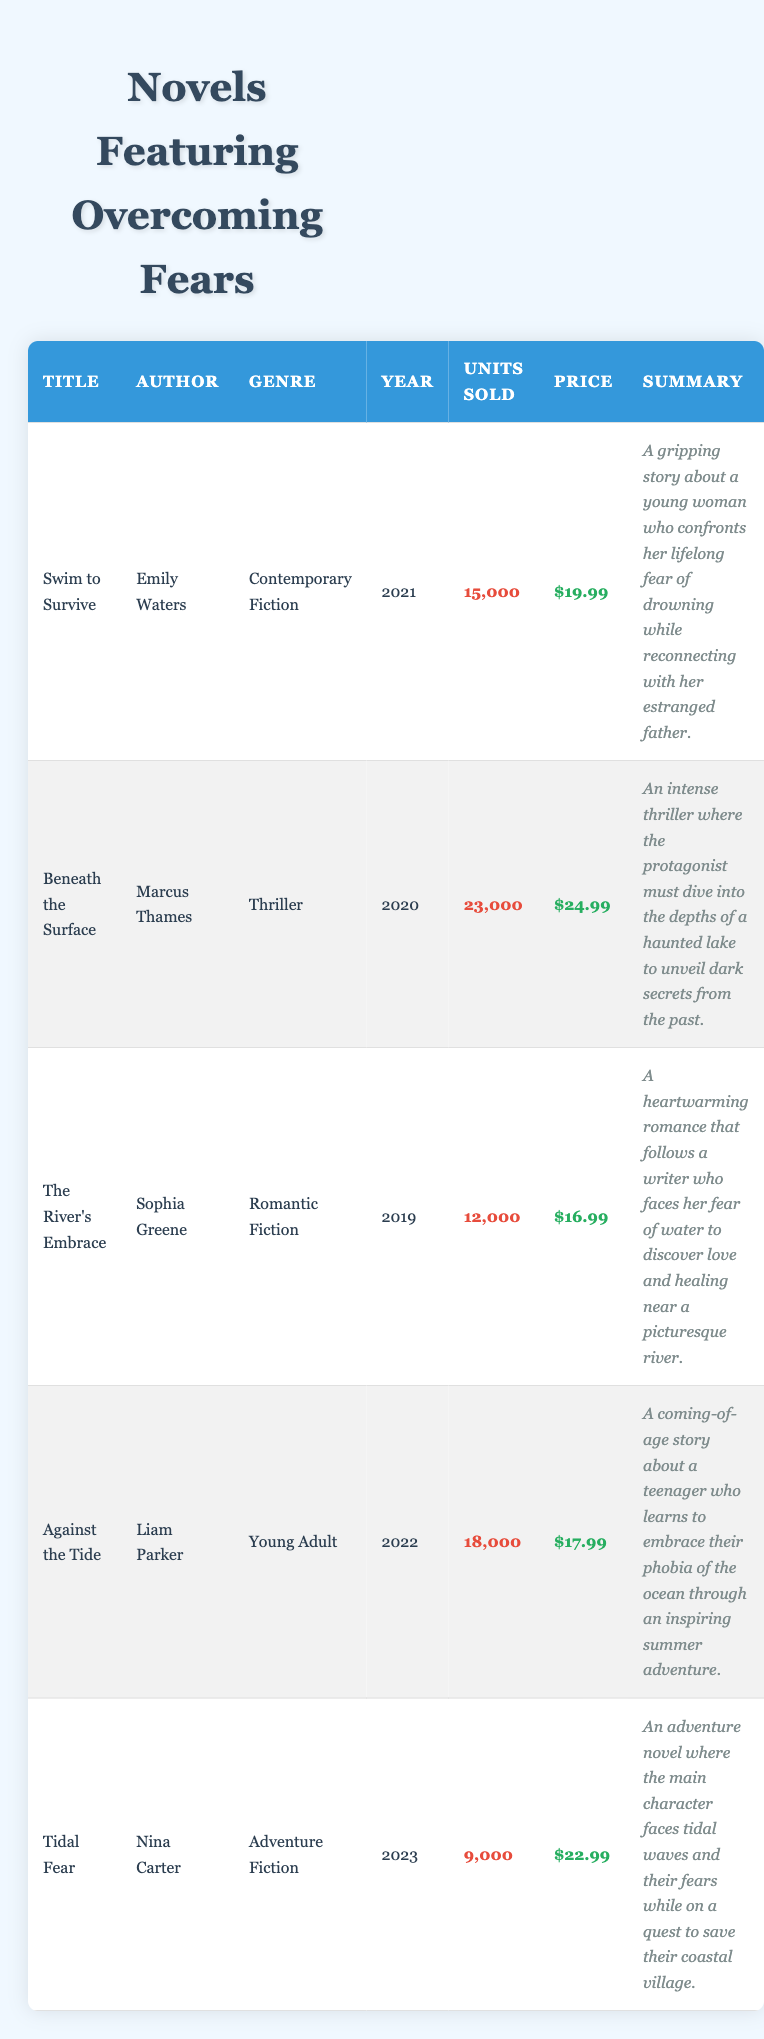What is the title of the book with the highest units sold? The table indicates that "Beneath the Surface" has the highest units sold with 23,000 sales.
Answer: Beneath the Surface How many units were sold for "The River's Embrace"? The table shows that "The River's Embrace" had 12,000 units sold.
Answer: 12,000 What is the average price of the books listed in the table? The prices are $19.99, $24.99, $16.99, $17.99, and $22.99. Adding them together gives $102.95. Dividing by 5 (the number of books) results in an average price of $20.59.
Answer: $20.59 Is "Against the Tide" a young adult novel? Yes, the genre listed for "Against the Tide" is Young Adult.
Answer: Yes Which author has the lowest units sold? The table shows that Nina Carter, author of "Tidal Fear," has the lowest units sold at 9,000.
Answer: Nina Carter What is the difference in units sold between "Swim to Survive" and "Tidal Fear"? "Swim to Survive" sold 15,000 units while "Tidal Fear" sold 9,000 units. The difference is 15,000 - 9,000 = 6,000.
Answer: 6,000 Do any of the books feature a water-related phobia? Yes, all listed books involve the theme of overcoming fears related to water.
Answer: Yes Which book was published most recently? "Tidal Fear" was published in 2023, making it the most recent book in the table.
Answer: Tidal Fear What is the total number of units sold across all the books? The total can be calculated by adding the units sold: 15,000 + 23,000 + 12,000 + 18,000 + 9,000 = 77,000 units sold in total.
Answer: 77,000 